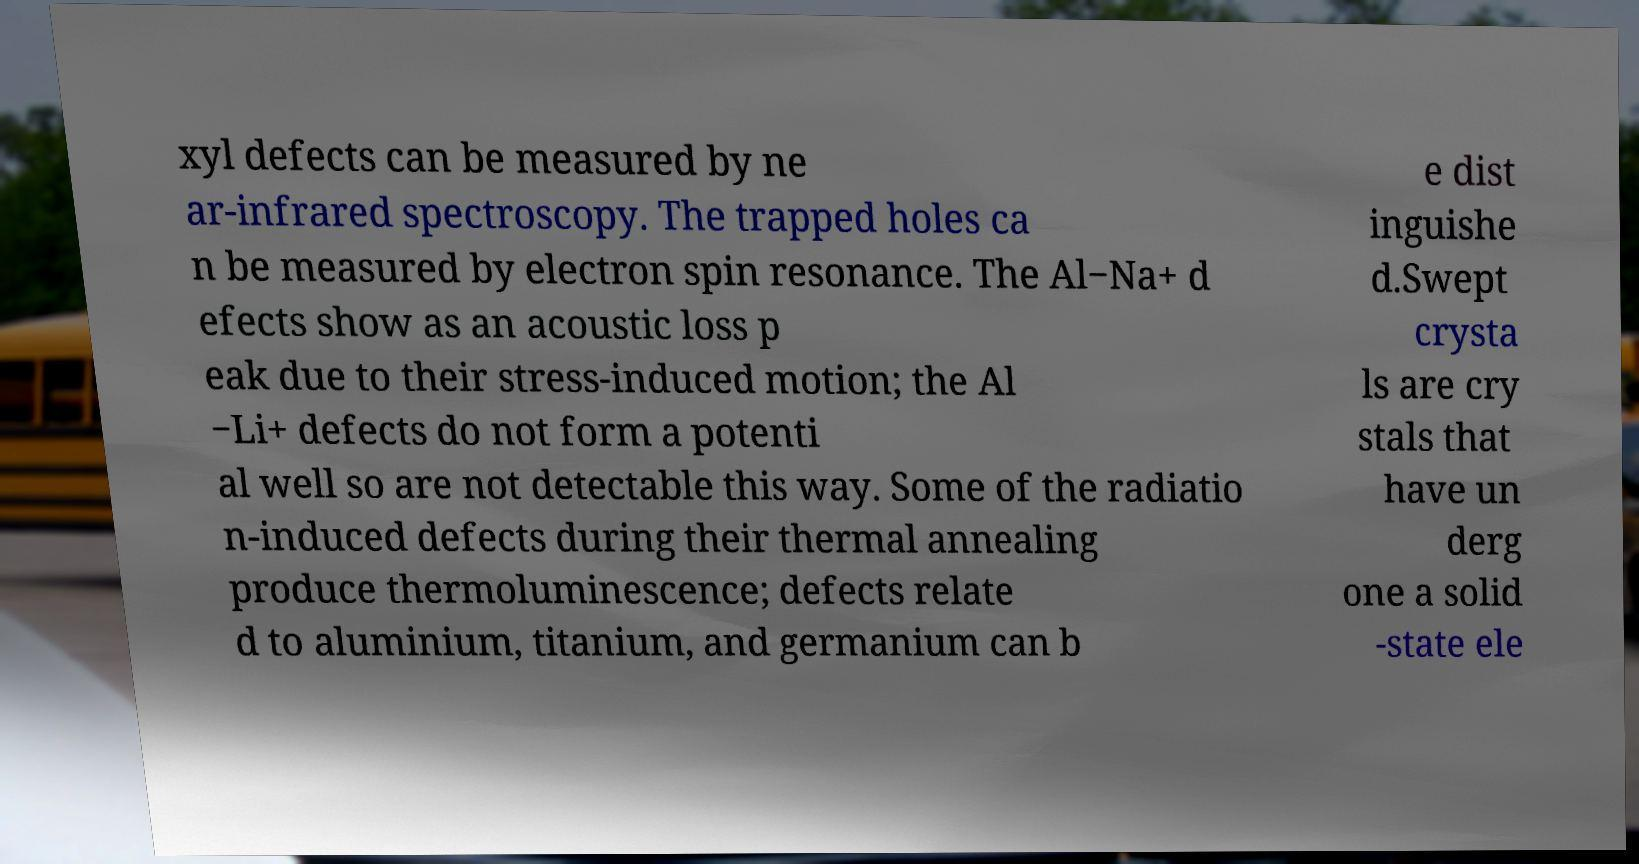Please read and relay the text visible in this image. What does it say? xyl defects can be measured by ne ar-infrared spectroscopy. The trapped holes ca n be measured by electron spin resonance. The Al−Na+ d efects show as an acoustic loss p eak due to their stress-induced motion; the Al −Li+ defects do not form a potenti al well so are not detectable this way. Some of the radiatio n-induced defects during their thermal annealing produce thermoluminescence; defects relate d to aluminium, titanium, and germanium can b e dist inguishe d.Swept crysta ls are cry stals that have un derg one a solid -state ele 